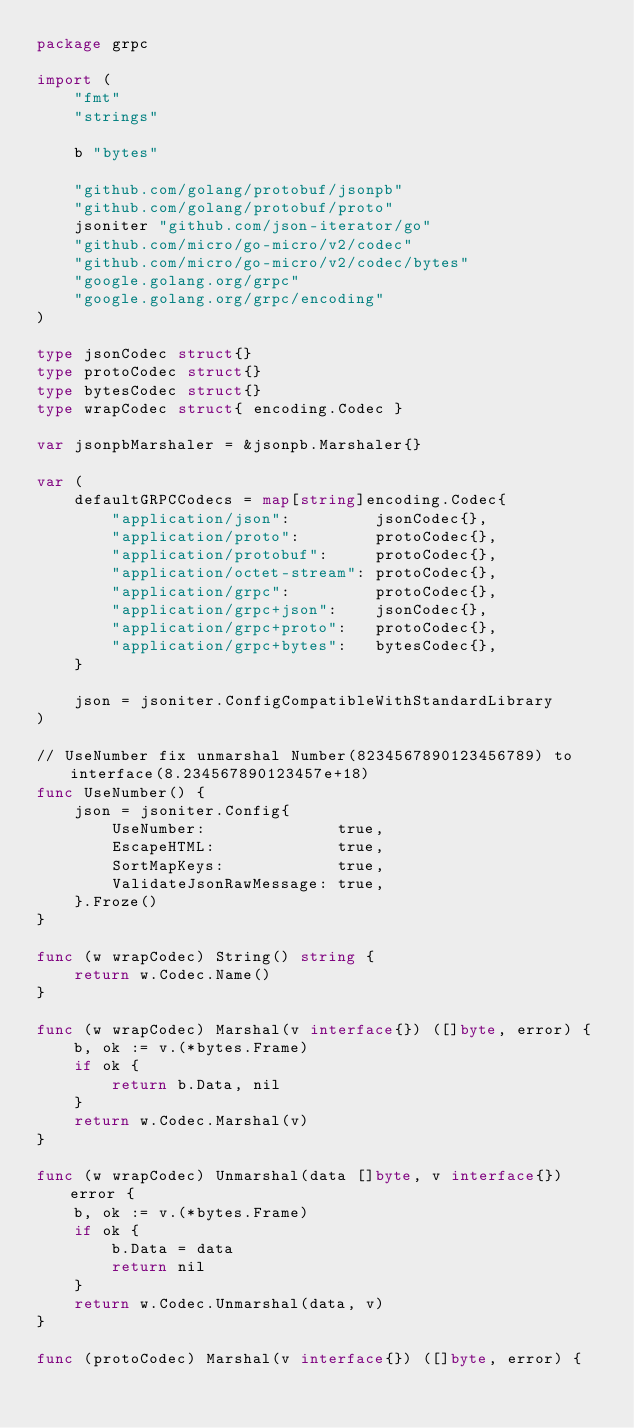Convert code to text. <code><loc_0><loc_0><loc_500><loc_500><_Go_>package grpc

import (
	"fmt"
	"strings"

	b "bytes"

	"github.com/golang/protobuf/jsonpb"
	"github.com/golang/protobuf/proto"
	jsoniter "github.com/json-iterator/go"
	"github.com/micro/go-micro/v2/codec"
	"github.com/micro/go-micro/v2/codec/bytes"
	"google.golang.org/grpc"
	"google.golang.org/grpc/encoding"
)

type jsonCodec struct{}
type protoCodec struct{}
type bytesCodec struct{}
type wrapCodec struct{ encoding.Codec }

var jsonpbMarshaler = &jsonpb.Marshaler{}

var (
	defaultGRPCCodecs = map[string]encoding.Codec{
		"application/json":         jsonCodec{},
		"application/proto":        protoCodec{},
		"application/protobuf":     protoCodec{},
		"application/octet-stream": protoCodec{},
		"application/grpc":         protoCodec{},
		"application/grpc+json":    jsonCodec{},
		"application/grpc+proto":   protoCodec{},
		"application/grpc+bytes":   bytesCodec{},
	}

	json = jsoniter.ConfigCompatibleWithStandardLibrary
)

// UseNumber fix unmarshal Number(8234567890123456789) to interface(8.234567890123457e+18)
func UseNumber() {
	json = jsoniter.Config{
		UseNumber:              true,
		EscapeHTML:             true,
		SortMapKeys:            true,
		ValidateJsonRawMessage: true,
	}.Froze()
}

func (w wrapCodec) String() string {
	return w.Codec.Name()
}

func (w wrapCodec) Marshal(v interface{}) ([]byte, error) {
	b, ok := v.(*bytes.Frame)
	if ok {
		return b.Data, nil
	}
	return w.Codec.Marshal(v)
}

func (w wrapCodec) Unmarshal(data []byte, v interface{}) error {
	b, ok := v.(*bytes.Frame)
	if ok {
		b.Data = data
		return nil
	}
	return w.Codec.Unmarshal(data, v)
}

func (protoCodec) Marshal(v interface{}) ([]byte, error) {</code> 